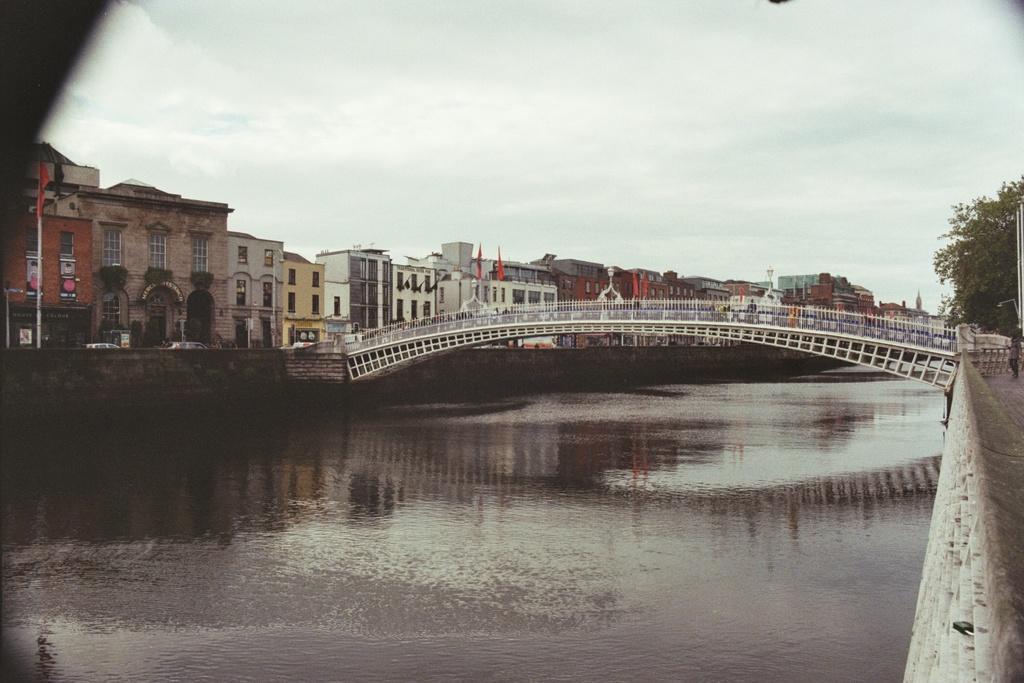In one or two sentences, can you explain what this image depicts? In this picture there are buildings and trees and poles and flags. In the middle of the image there is a bridge. On the right side of the image there is a person standing on the road. At the top there is sky and there are clouds. At the bottom there is water. 